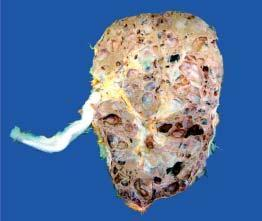s the apex enlarged and heavy?
Answer the question using a single word or phrase. No 